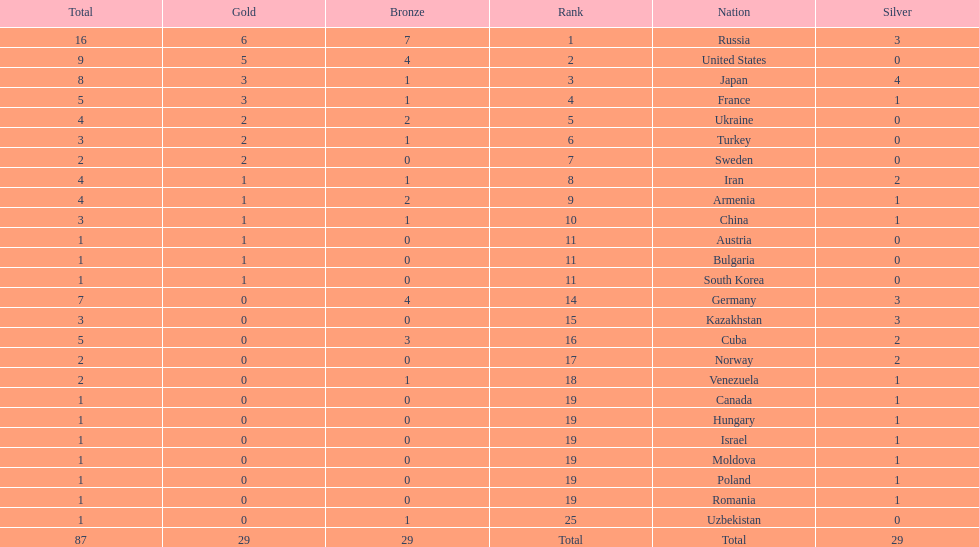Which country had the highest number of medals? Russia. 